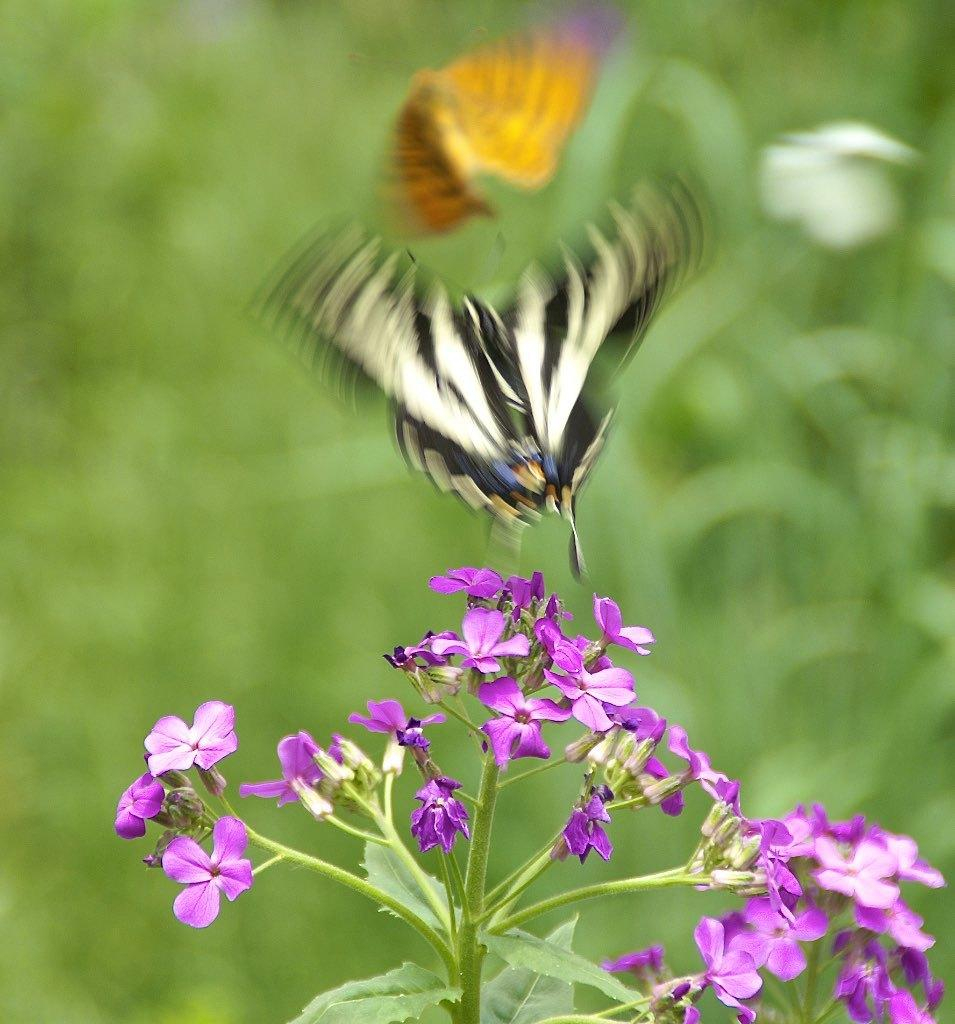What is the main subject of the image? There is a butterfly in the image. Where is the butterfly located? The butterfly is in the air. What other objects can be seen in the image? There are flowers and a plant in the image. How would you describe the background of the image? The background of the image is blurred and green. What type of drawer is visible in the image? There is no drawer present in the image. Is the butterfly in jail in the image? No, the butterfly is not in jail; it is in the air. 